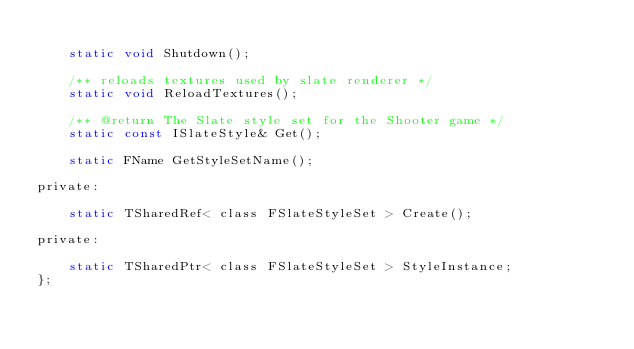Convert code to text. <code><loc_0><loc_0><loc_500><loc_500><_C_>
	static void Shutdown();

	/** reloads textures used by slate renderer */
	static void ReloadTextures();

	/** @return The Slate style set for the Shooter game */
	static const ISlateStyle& Get();

	static FName GetStyleSetName();

private:

	static TSharedRef< class FSlateStyleSet > Create();

private:

	static TSharedPtr< class FSlateStyleSet > StyleInstance;
};</code> 